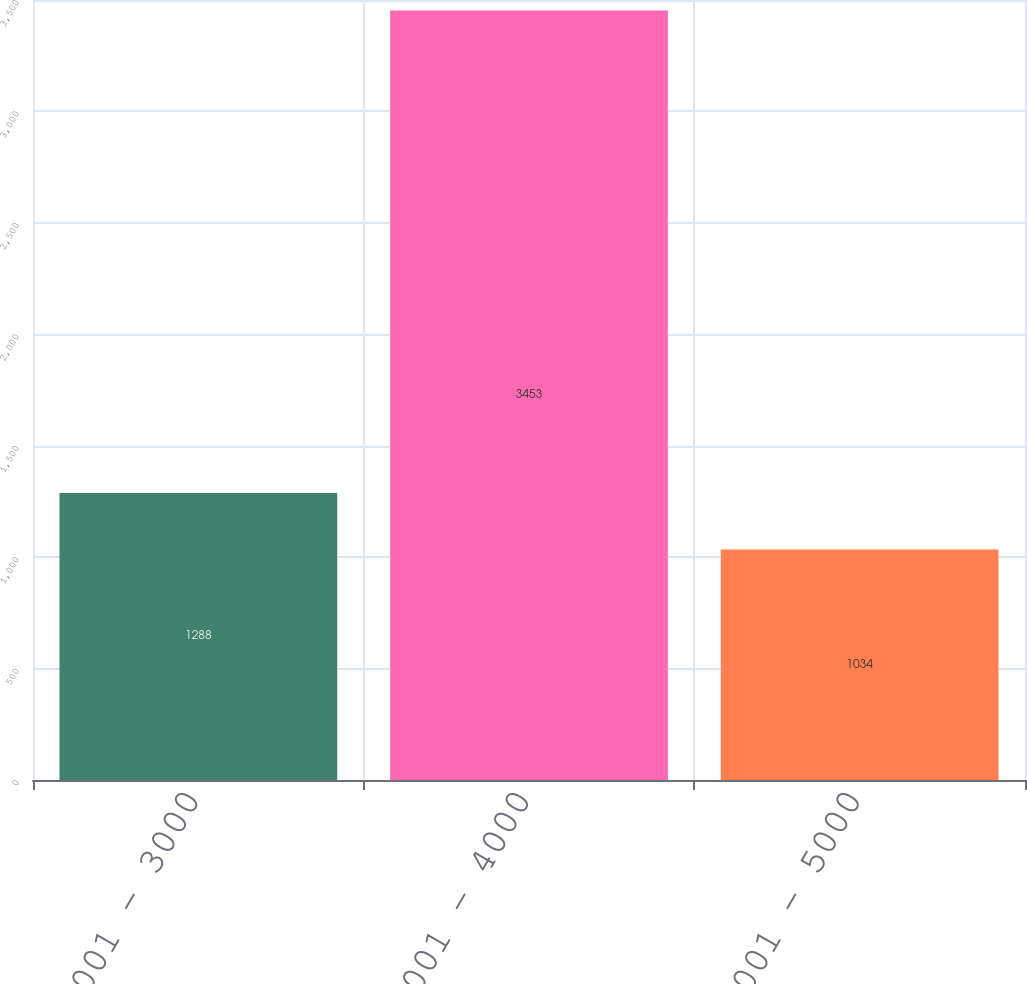<chart> <loc_0><loc_0><loc_500><loc_500><bar_chart><fcel>2001 - 3000<fcel>3001 - 4000<fcel>4001 - 5000<nl><fcel>1288<fcel>3453<fcel>1034<nl></chart> 